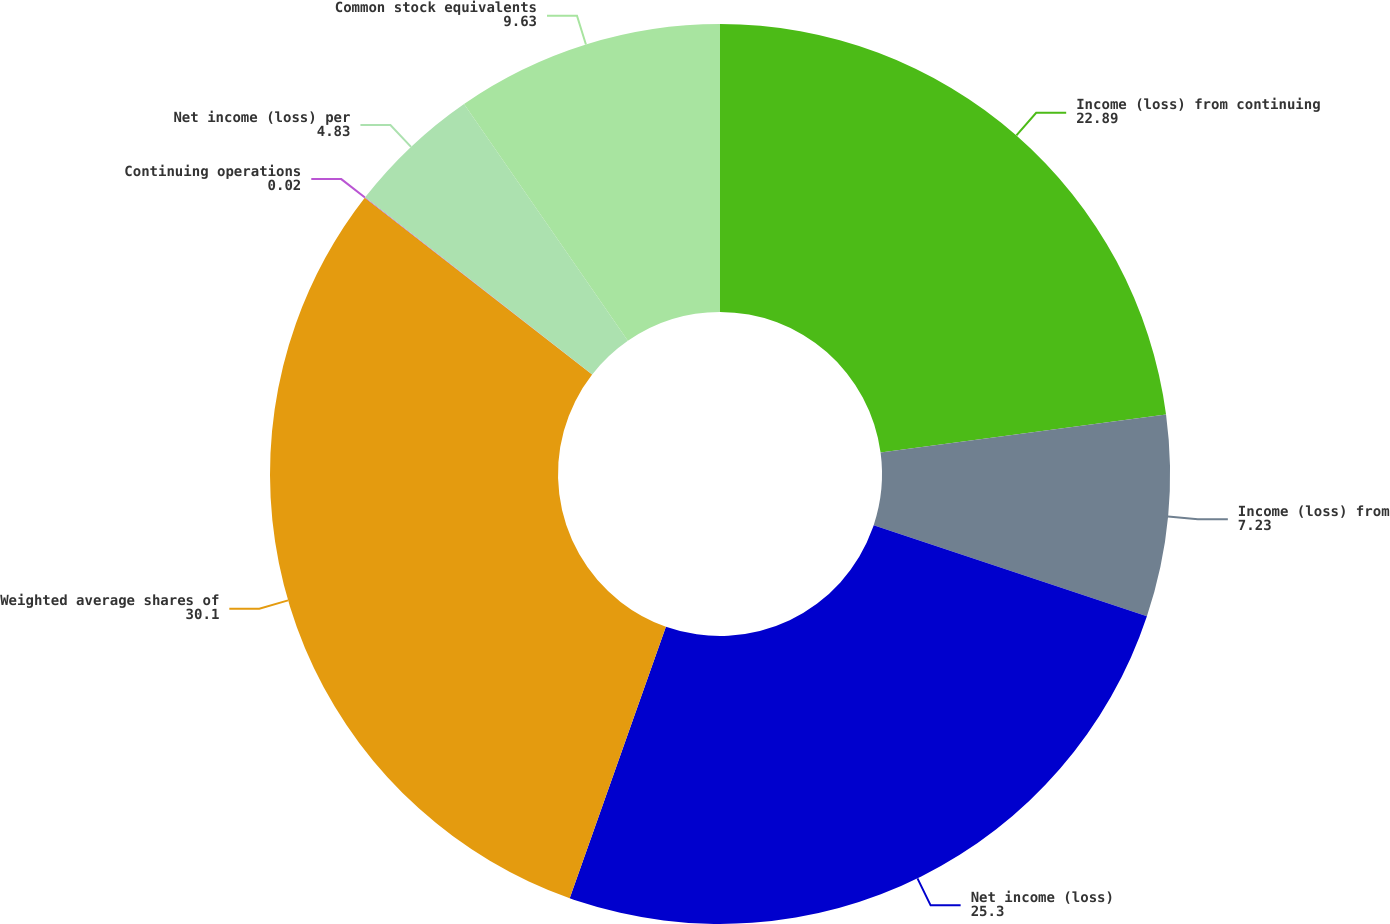Convert chart. <chart><loc_0><loc_0><loc_500><loc_500><pie_chart><fcel>Income (loss) from continuing<fcel>Income (loss) from<fcel>Net income (loss)<fcel>Weighted average shares of<fcel>Continuing operations<fcel>Net income (loss) per<fcel>Common stock equivalents<nl><fcel>22.89%<fcel>7.23%<fcel>25.3%<fcel>30.1%<fcel>0.02%<fcel>4.83%<fcel>9.63%<nl></chart> 